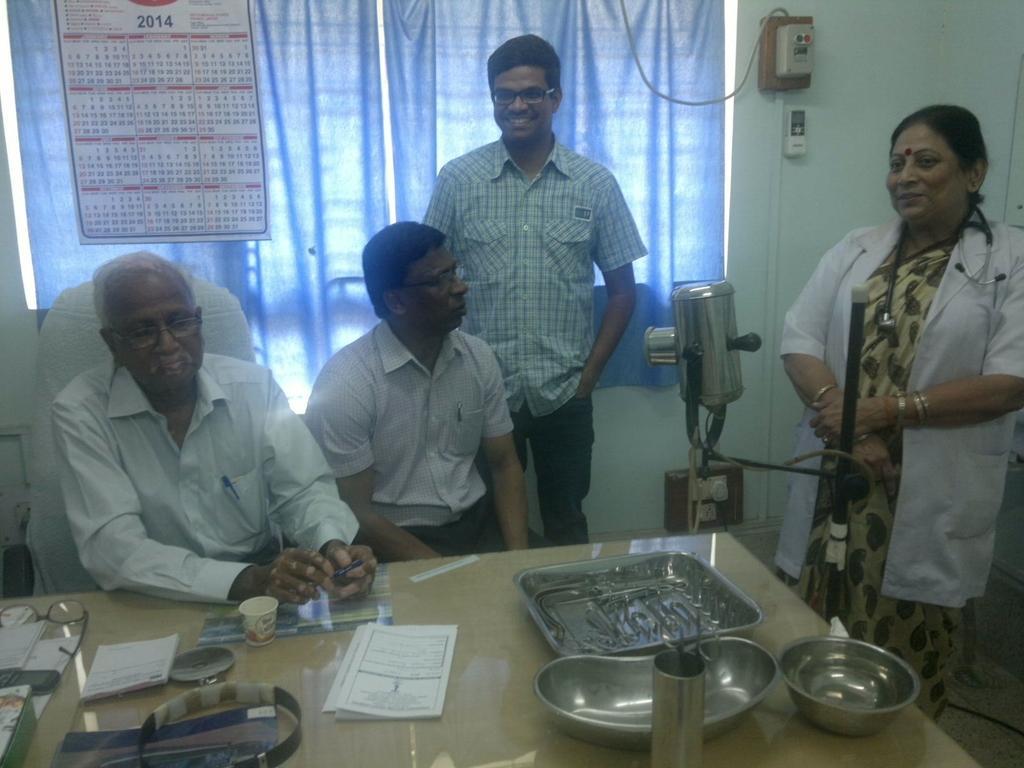Describe this image in one or two sentences. In the picture we can see two men are sitting near the table on the table, we can see a tray, and a glass with scissors, papers, slips and beside the table, we can see a woman standing she is in a white coat, and stethoscope and beside her we can see one man standing and smiling and in the background, we can see a wall with a window and a blue color curtain to it and on it we can see a calendar and on the wall we can see a switch. 